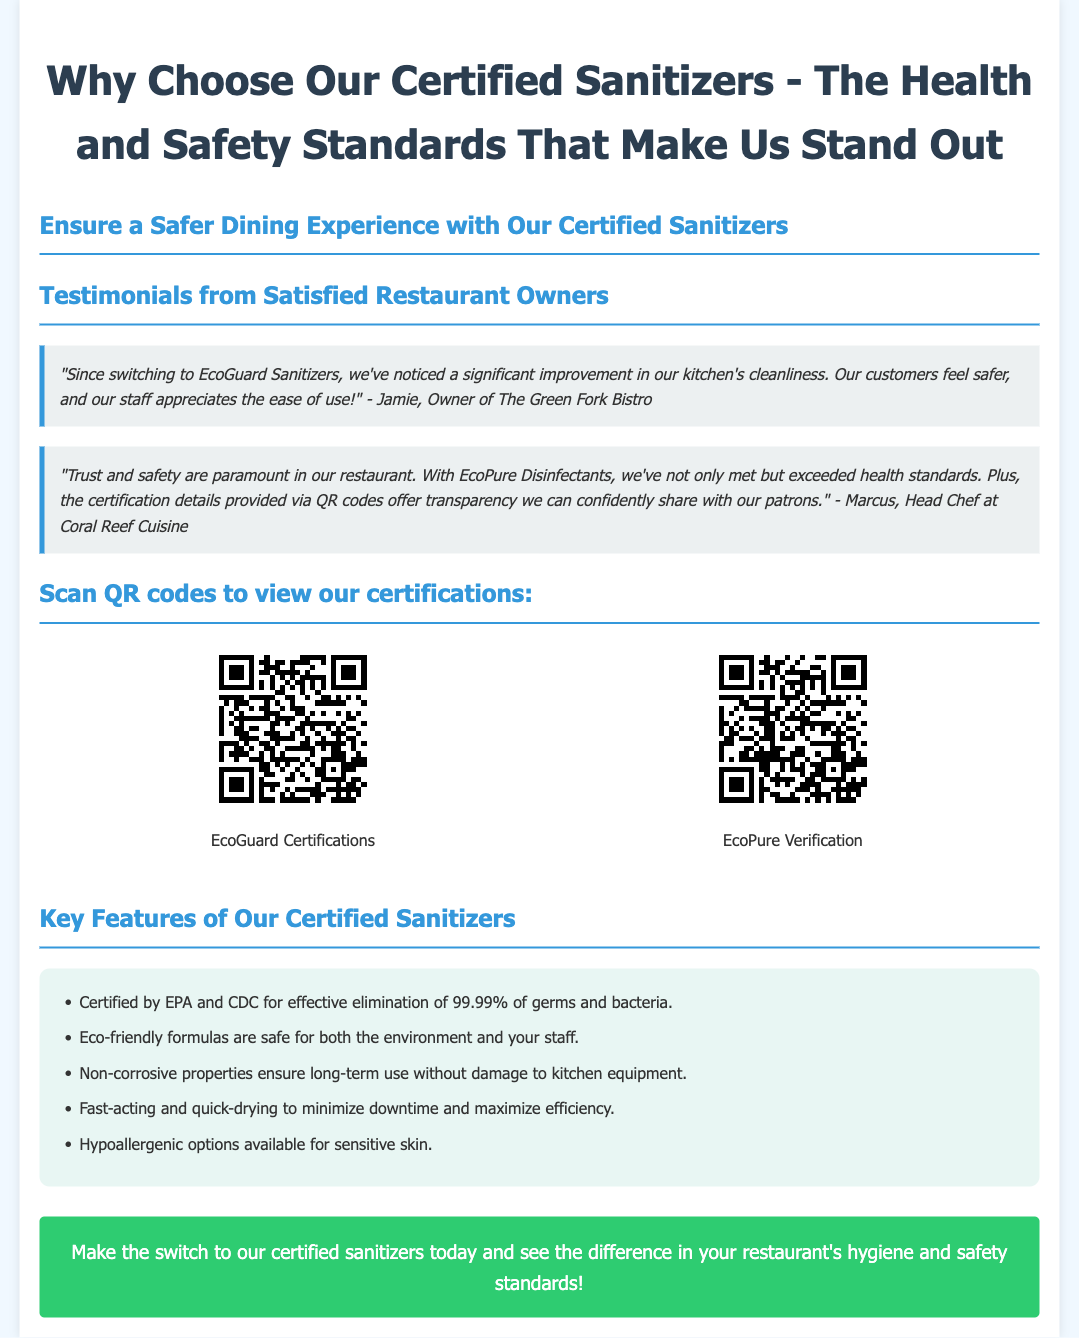What is the name of the owner who provided a testimonial? Jamie, the owner of The Green Fork Bistro, gives a testimonial about the sanitizers.
Answer: Jamie What percentage of germs and bacteria do the sanitizers eliminate? The document states that the sanitizers eliminate 99.99% of germs and bacteria.
Answer: 99.99% Which company offers EcoPure Disinfectants? A testimonial mentions EcoPure Disinfectants, highlighting their effectiveness and safety standards.
Answer: EcoPure What kind of properties do the sanitizers have to prevent damage to kitchen equipment? The sanitizers have non-corrosive properties, which ensure they do not damage kitchen equipment over time.
Answer: Non-corrosive How many QR codes are provided in the document? There are two QR codes linked to certification details for the sanitizers.
Answer: Two What is the call to action presented at the end of the advertisement? The call to action encourages readers to make the switch to certified sanitizers and see the difference in hygiene.
Answer: Make the switch today Who is the head chef that provided a testimonial? Marcus, the head chef at Coral Reef Cuisine, provided a testimonial regarding the sanitizers.
Answer: Marcus What type of options are available for users with sensitive skin? The document mentions that hypoallergenic options are available for sensitive skin.
Answer: Hypoallergenic 